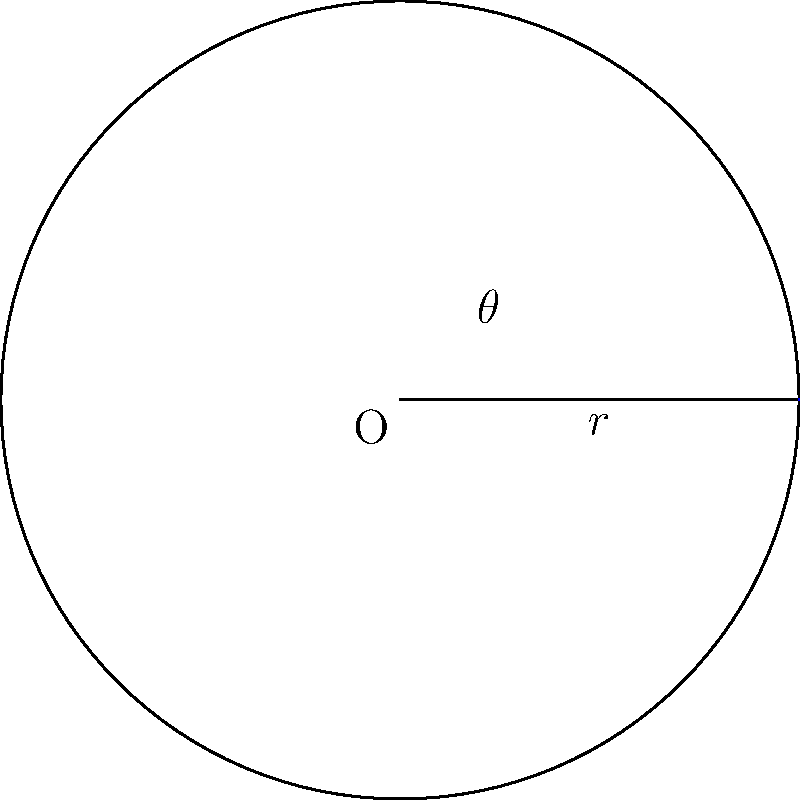In honor of Anatoliy Smirnov's groundbreaking work on circular geometry, consider a circle with radius $r = 3$ cm and a central angle $\theta = 2.1$ radians. Calculate the area of the sector formed by this angle, rounding your answer to two decimal places. Let's approach this step-by-step, as Anatoliy would have:

1) The formula for the area of a sector is:

   $A = \frac{1}{2}r^2\theta$

   Where $A$ is the area, $r$ is the radius, and $\theta$ is the central angle in radians.

2) We are given:
   $r = 3$ cm
   $\theta = 2.1$ radians

3) Let's substitute these values into our formula:

   $A = \frac{1}{2}(3\text{ cm})^2(2.1\text{ rad})$

4) First, let's calculate $r^2$:
   
   $(3\text{ cm})^2 = 9\text{ cm}^2$

5) Now our equation looks like:

   $A = \frac{1}{2}(9\text{ cm}^2)(2.1\text{ rad})$

6) Multiply:
   
   $A = 9.45\text{ cm}^2$

7) Rounding to two decimal places:

   $A \approx 9.45\text{ cm}^2$
Answer: $9.45\text{ cm}^2$ 